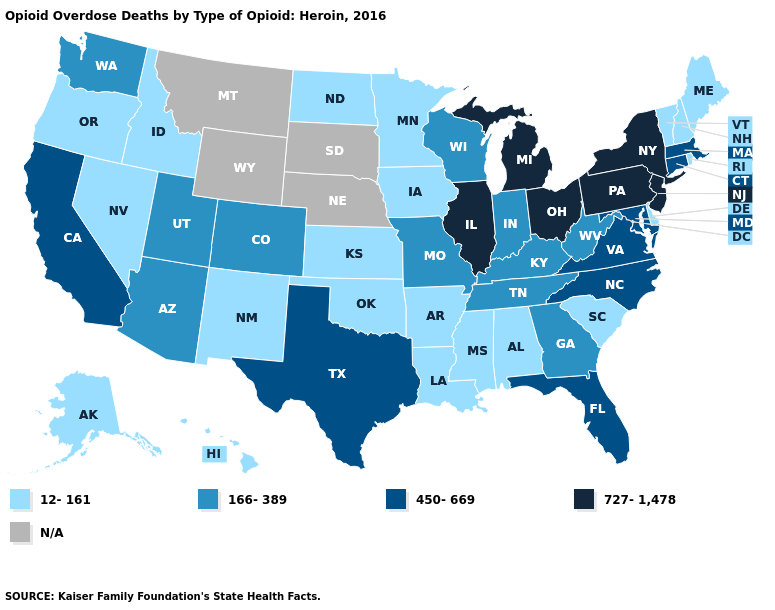What is the value of Delaware?
Short answer required. 12-161. What is the value of New Hampshire?
Be succinct. 12-161. Name the states that have a value in the range 727-1,478?
Keep it brief. Illinois, Michigan, New Jersey, New York, Ohio, Pennsylvania. Does South Carolina have the lowest value in the South?
Short answer required. Yes. Name the states that have a value in the range 727-1,478?
Short answer required. Illinois, Michigan, New Jersey, New York, Ohio, Pennsylvania. Name the states that have a value in the range N/A?
Be succinct. Montana, Nebraska, South Dakota, Wyoming. Name the states that have a value in the range 12-161?
Give a very brief answer. Alabama, Alaska, Arkansas, Delaware, Hawaii, Idaho, Iowa, Kansas, Louisiana, Maine, Minnesota, Mississippi, Nevada, New Hampshire, New Mexico, North Dakota, Oklahoma, Oregon, Rhode Island, South Carolina, Vermont. Name the states that have a value in the range N/A?
Give a very brief answer. Montana, Nebraska, South Dakota, Wyoming. Name the states that have a value in the range 12-161?
Concise answer only. Alabama, Alaska, Arkansas, Delaware, Hawaii, Idaho, Iowa, Kansas, Louisiana, Maine, Minnesota, Mississippi, Nevada, New Hampshire, New Mexico, North Dakota, Oklahoma, Oregon, Rhode Island, South Carolina, Vermont. What is the value of North Dakota?
Be succinct. 12-161. Name the states that have a value in the range N/A?
Be succinct. Montana, Nebraska, South Dakota, Wyoming. What is the highest value in the South ?
Concise answer only. 450-669. Among the states that border Maryland , does West Virginia have the lowest value?
Short answer required. No. Which states hav the highest value in the South?
Keep it brief. Florida, Maryland, North Carolina, Texas, Virginia. 